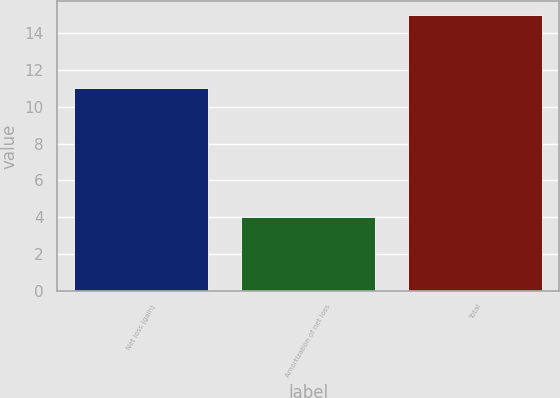<chart> <loc_0><loc_0><loc_500><loc_500><bar_chart><fcel>Net loss (gain)<fcel>Amortization of net loss<fcel>Total<nl><fcel>11<fcel>4<fcel>15<nl></chart> 